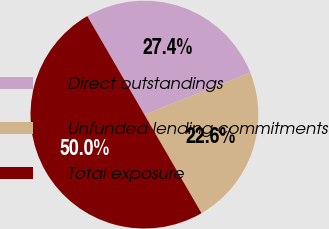<chart> <loc_0><loc_0><loc_500><loc_500><pie_chart><fcel>Direct outstandings<fcel>Unfunded lending commitments<fcel>Total exposure<nl><fcel>27.35%<fcel>22.65%<fcel>50.0%<nl></chart> 